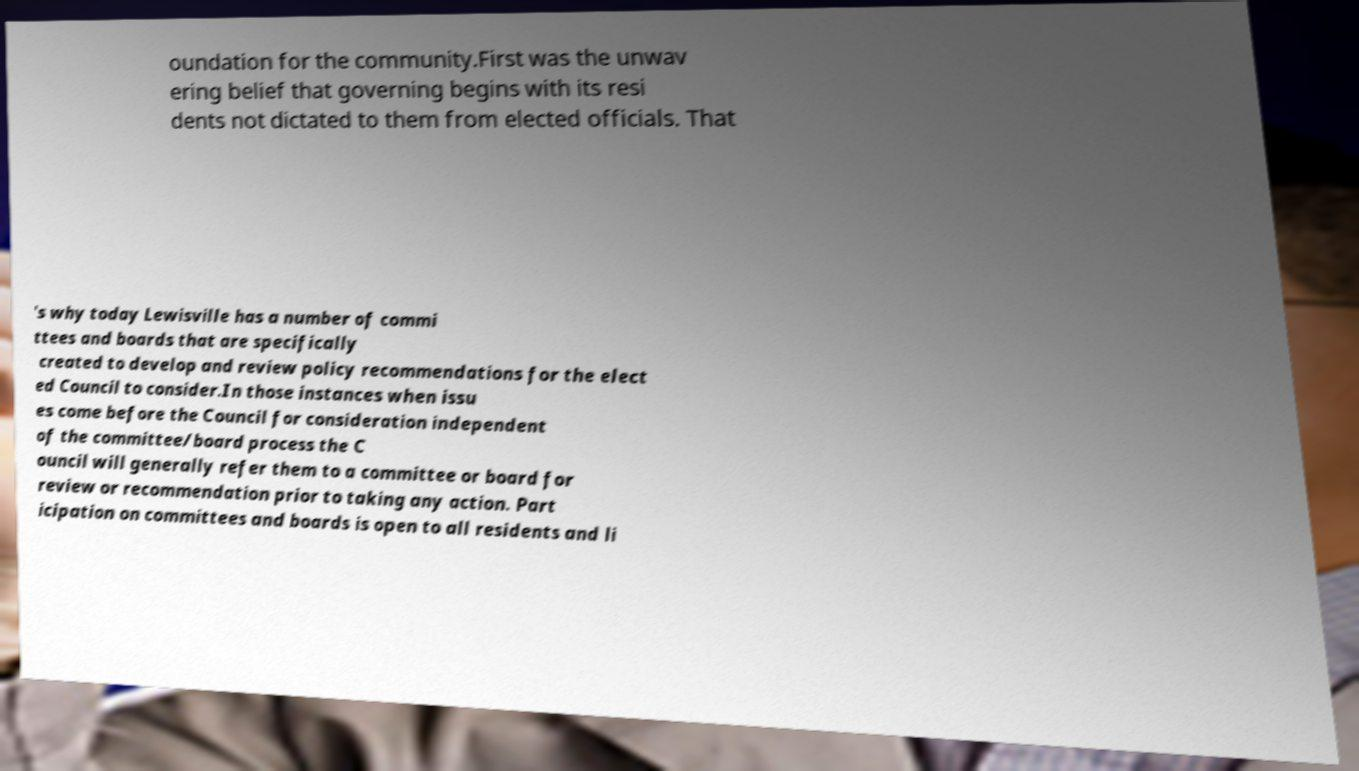Please read and relay the text visible in this image. What does it say? oundation for the community.First was the unwav ering belief that governing begins with its resi dents not dictated to them from elected officials. That 's why today Lewisville has a number of commi ttees and boards that are specifically created to develop and review policy recommendations for the elect ed Council to consider.In those instances when issu es come before the Council for consideration independent of the committee/board process the C ouncil will generally refer them to a committee or board for review or recommendation prior to taking any action. Part icipation on committees and boards is open to all residents and li 